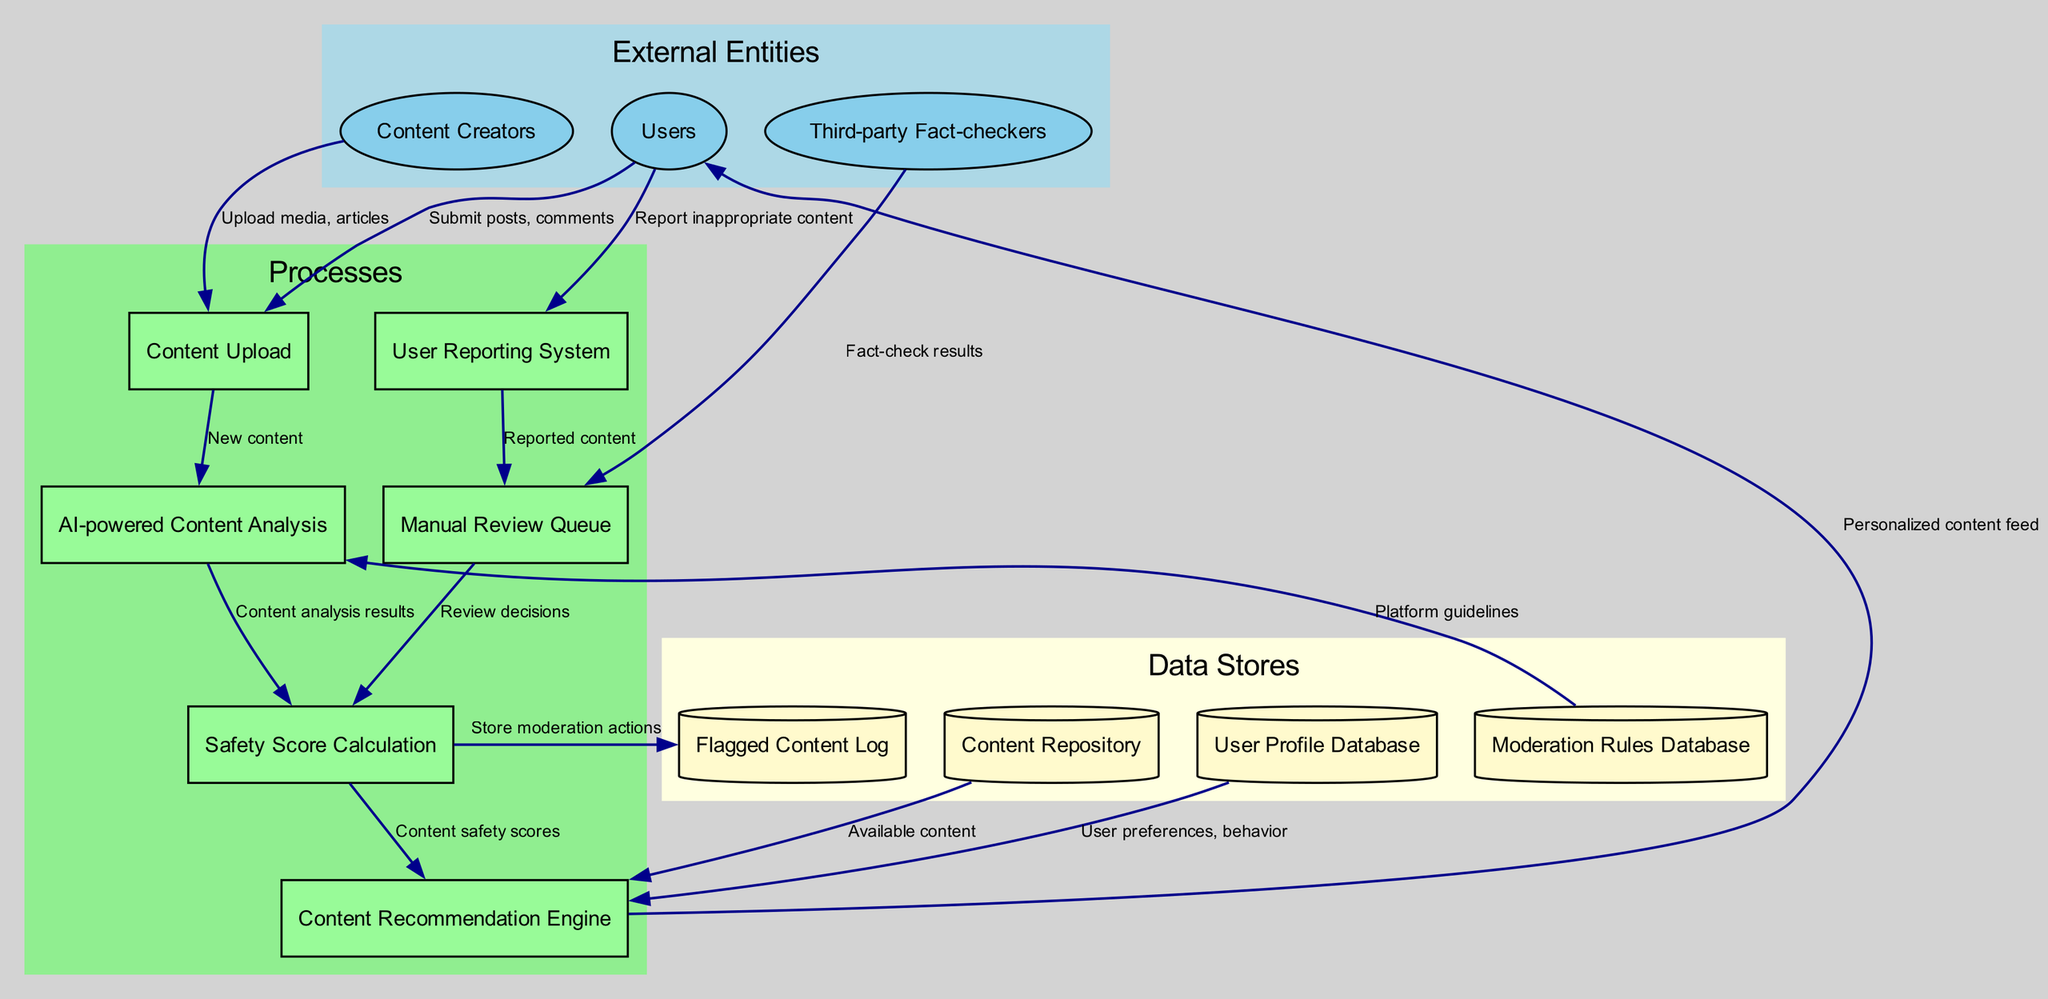What external entities are involved in the process? The external entities listed in the diagram include Users, Content Creators, and Third-party Fact-checkers.
Answer: Users, Content Creators, Third-party Fact-checkers How many processes are defined in the diagram? The processes in the diagram include Content Upload, AI-powered Content Analysis, User Reporting System, Manual Review Queue, Content Recommendation Engine, and Safety Score Calculation. Counting these gives a total of 6 processes.
Answer: 6 What is the data flow from Users to User Reporting System? The data flow from Users to the User Reporting System is labeled as "Report inappropriate content." This indicates that users submit reports of inappropriate content.
Answer: Report inappropriate content Which process analyzes content after it's uploaded? After content is uploaded, it flows to "AI-powered Content Analysis," where the content is analyzed for various factors.
Answer: AI-powered Content Analysis What data store does the Safety Score Calculation process write to? The Safety Score Calculation process writes moderation actions to the "Flagged Content Log," storing information about moderation actions taken.
Answer: Flagged Content Log How many data stores are present in the diagram? The diagram features four data stores: User Profile Database, Content Repository, Moderation Rules Database, and Flagged Content Log. Counting these gives a total of 4 data stores.
Answer: 4 What information does the Content Recommendation Engine receive? The Content Recommendation Engine receives user preferences and behavior from the User Profile Database, available content from the Content Repository, and content safety scores from the Safety Score Calculation process.
Answer: User preferences, behavior; Available content; Content safety scores Which process receives fact-check results? The Manual Review Queue receives fact-check results from Third-party Fact-checkers, which can help inform moderation decisions based on external evaluations.
Answer: Manual Review Queue How is the content recommendation personalized for users? The Content Recommendation Engine personalizes content for users based on data received from the User Profile Database and content safety scores from the Safety Score Calculation process, configuring the personalized content feed accordingly.
Answer: Personalized content feed 